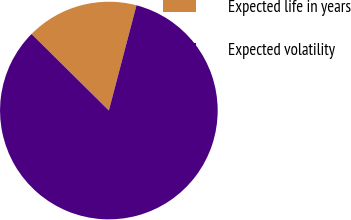<chart> <loc_0><loc_0><loc_500><loc_500><pie_chart><fcel>Expected life in years<fcel>Expected volatility<nl><fcel>16.67%<fcel>83.33%<nl></chart> 